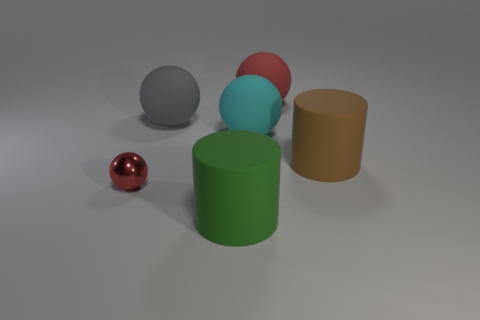There is another matte cylinder that is the same size as the brown cylinder; what color is it?
Provide a succinct answer. Green. What number of objects are either matte objects that are on the right side of the red rubber object or small spheres?
Your response must be concise. 2. What number of other things are the same size as the gray matte object?
Provide a succinct answer. 4. There is a red thing that is in front of the big brown rubber object; what is its size?
Your response must be concise. Small. What is the shape of the big cyan object that is made of the same material as the big red sphere?
Provide a succinct answer. Sphere. Is there anything else that has the same color as the small ball?
Make the answer very short. Yes. The big matte cylinder on the right side of the rubber object in front of the small ball is what color?
Keep it short and to the point. Brown. What number of big things are red spheres or brown rubber cylinders?
Keep it short and to the point. 2. What material is the other large thing that is the same shape as the big green matte object?
Offer a terse response. Rubber. Are there any other things that are the same material as the tiny thing?
Offer a terse response. No. 